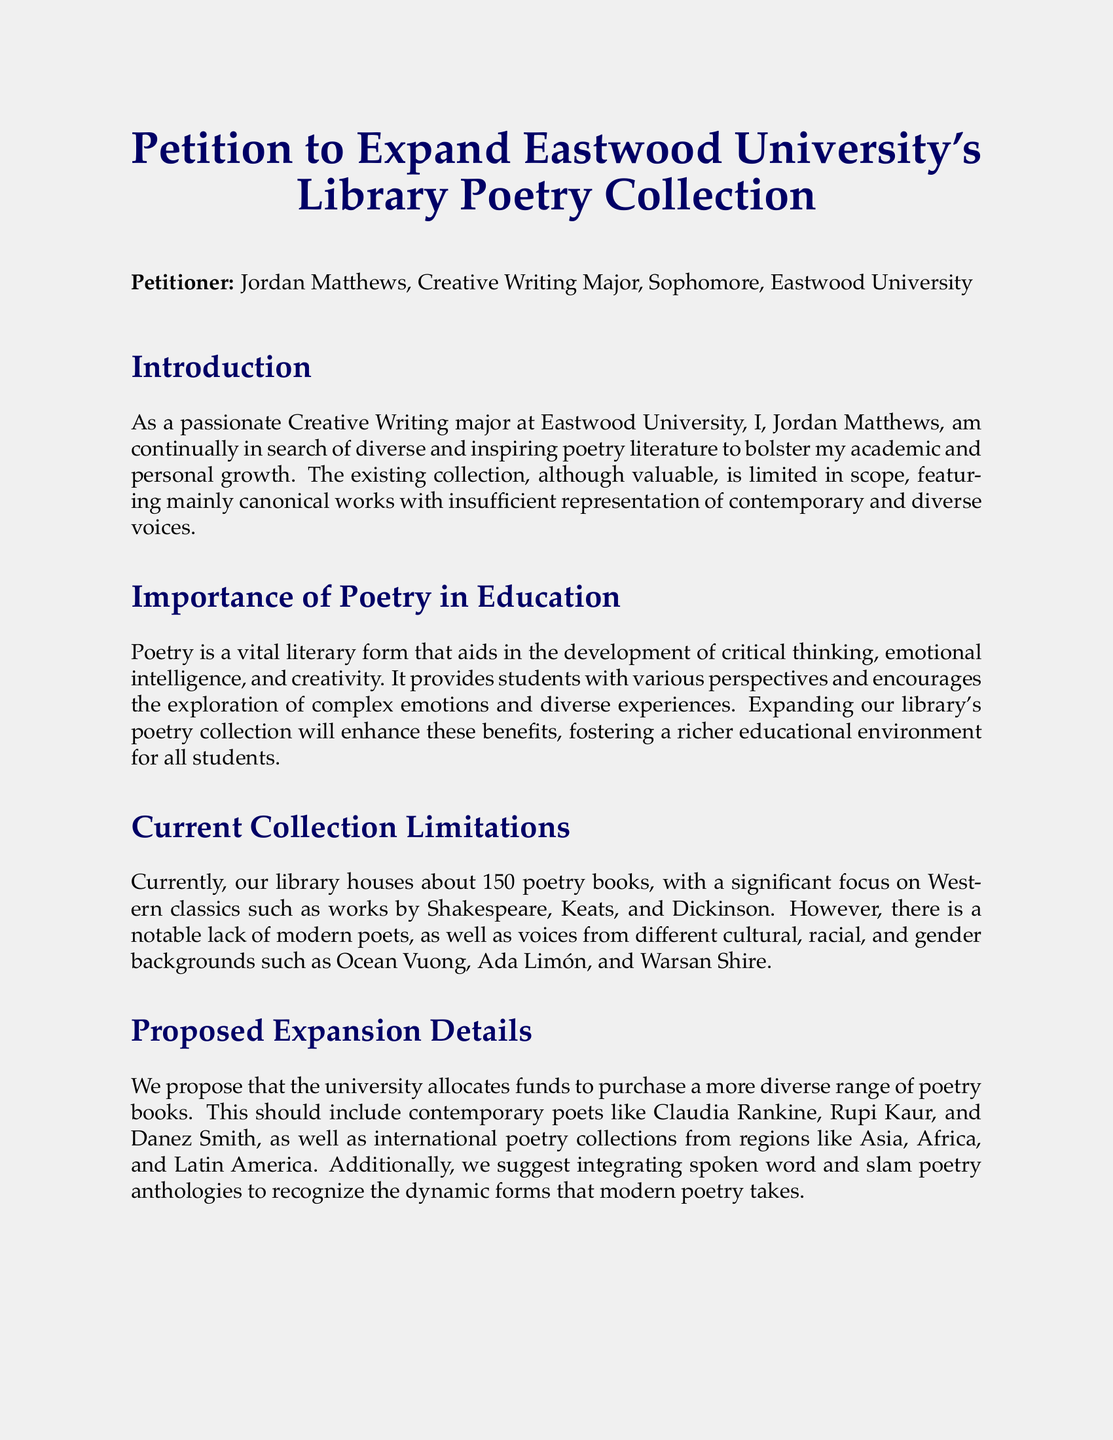What is the name of the petitioner? The name of the petitioner is stated in the document, which is Jordan Matthews.
Answer: Jordan Matthews How many poetry books are currently housed in the library? The document mentions the total number of poetry books presently available in the library.
Answer: 150 Which poet is mentioned as lacking representation in the current collection? The document provides examples of poets whose works should be included but are currently not represented.
Answer: Ocean Vuong What is the proposed action for the college library? The document describes the main goal of the petition regarding the library’s poetry collection.
Answer: Expand the collection Name one contemporary poet suggested for inclusion. The proposed expansion details include names of contemporary poets that could enrich the collection.
Answer: Claudia Rankine According to studies cited, what can exposure to diverse poetic voices enhance? The document refers to the benefits of a broader poetic collection as shown by studies.
Answer: Academic performance What type of poetry should be integrated according to the proposal? The proposed expansion includes specific types of poetry that reflect modern trends.
Answer: Spoken word What is the main focus of the current poetry collection? The document outlines the primary literary focus of the current poetry collection.
Answer: Western classics 